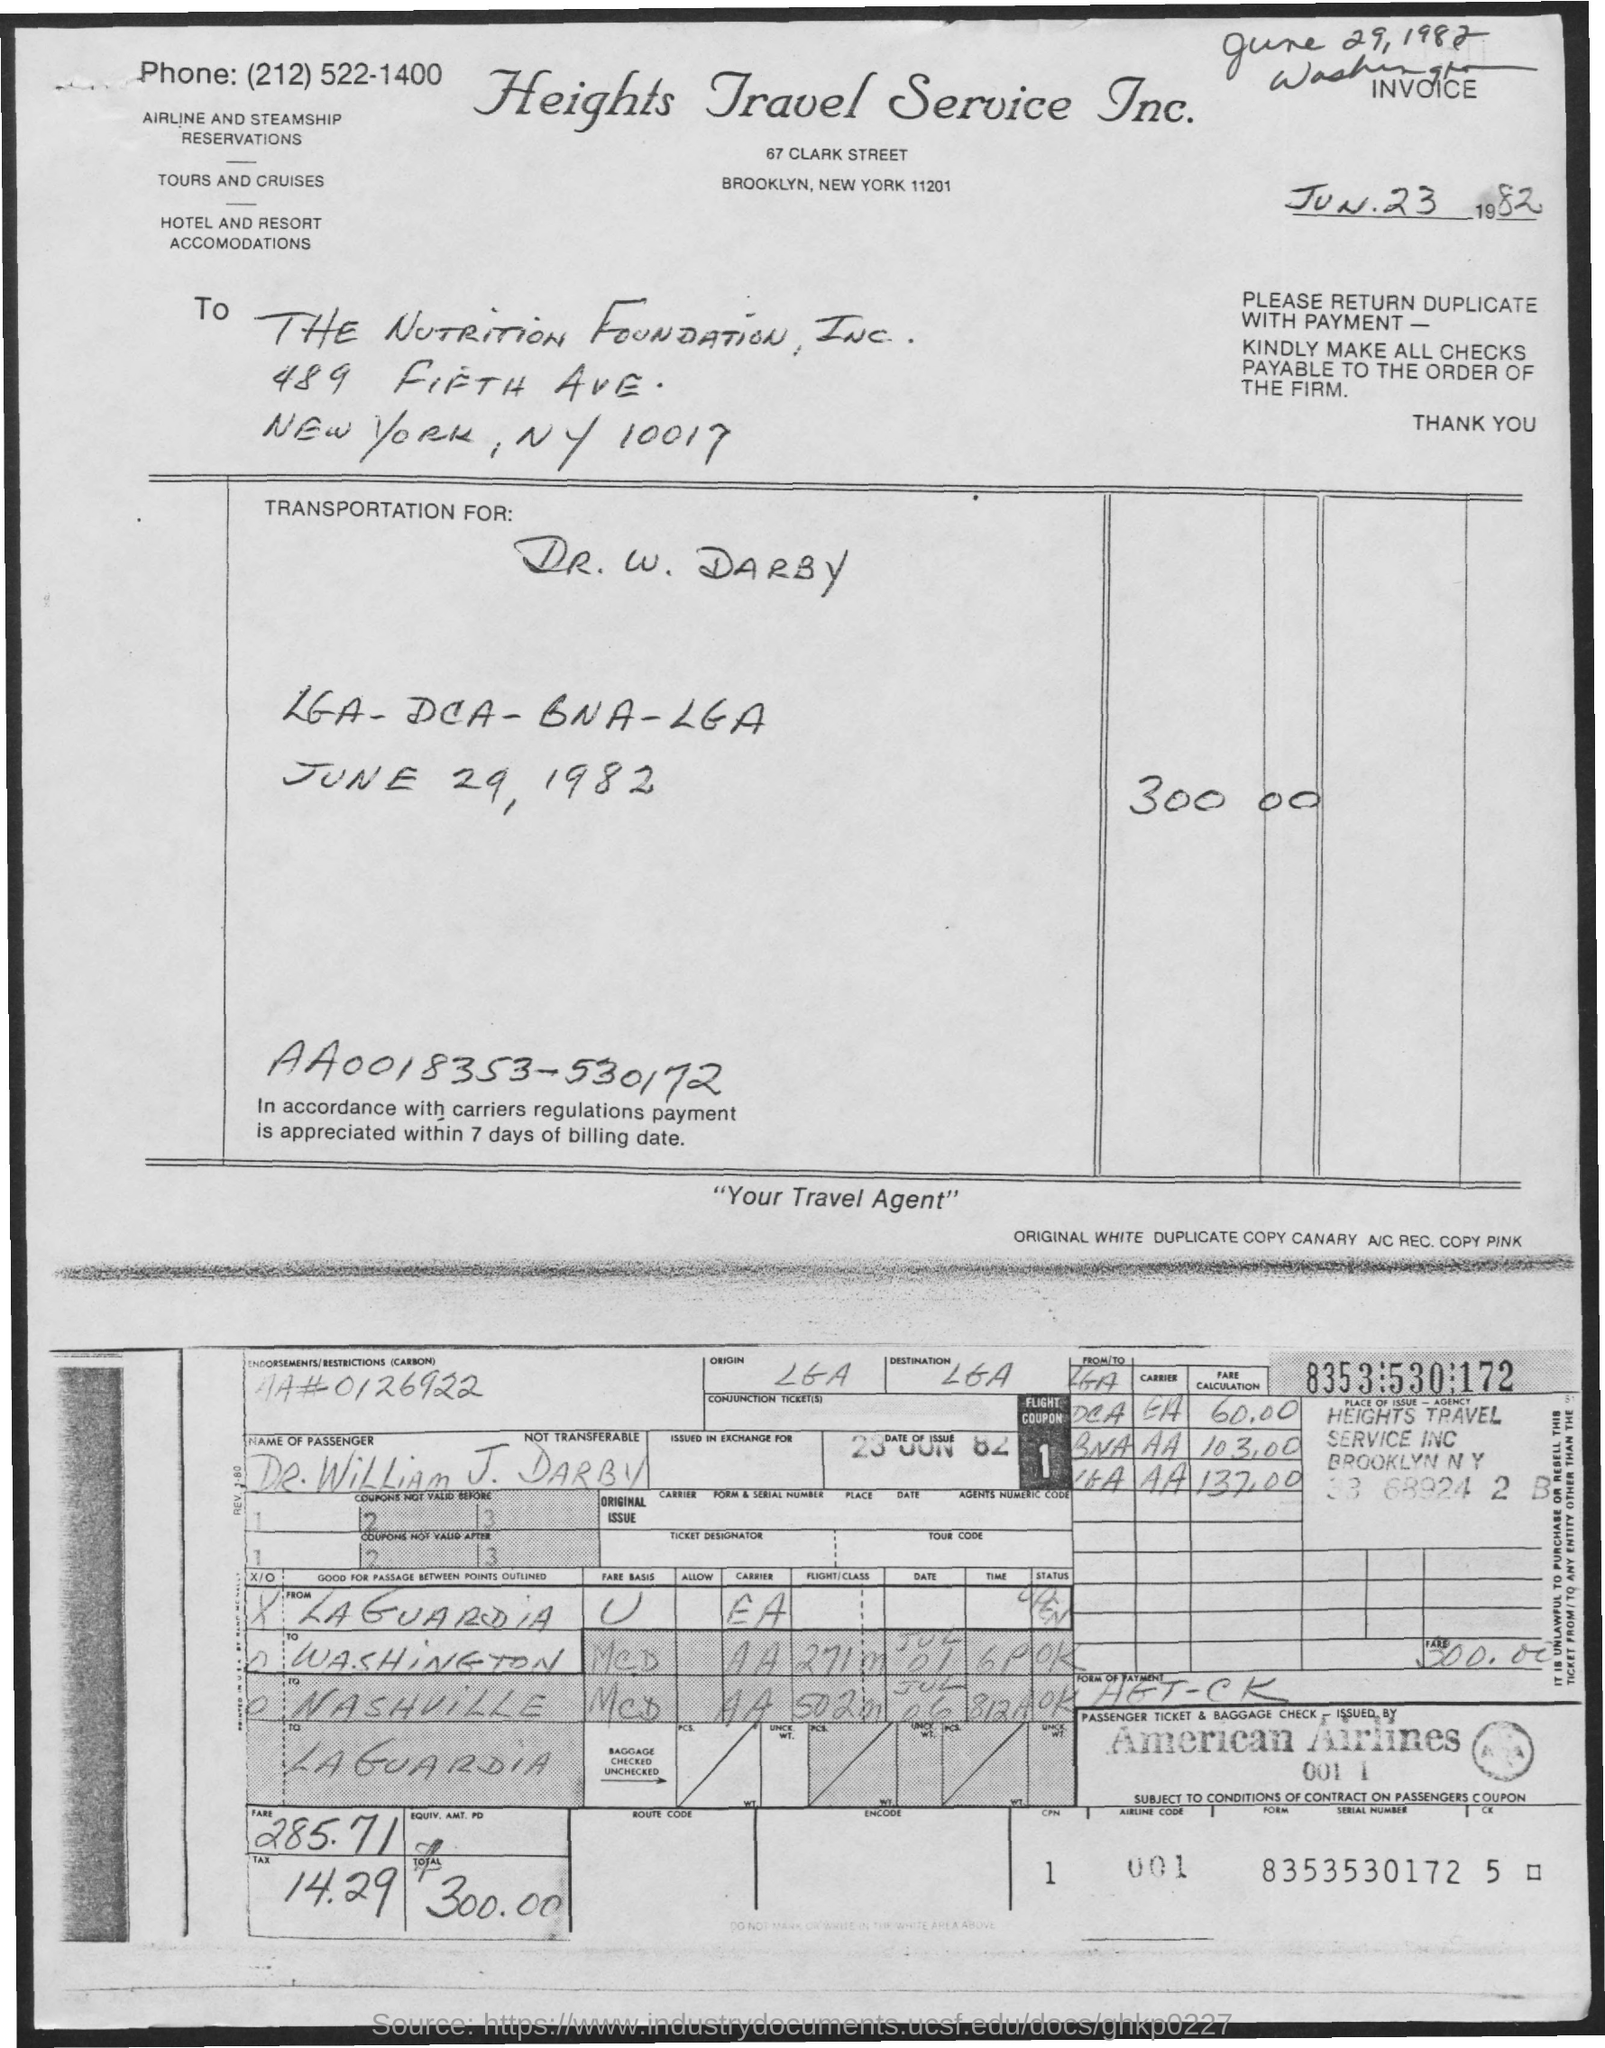what is the postal code for nutrition foundation?
 10017 